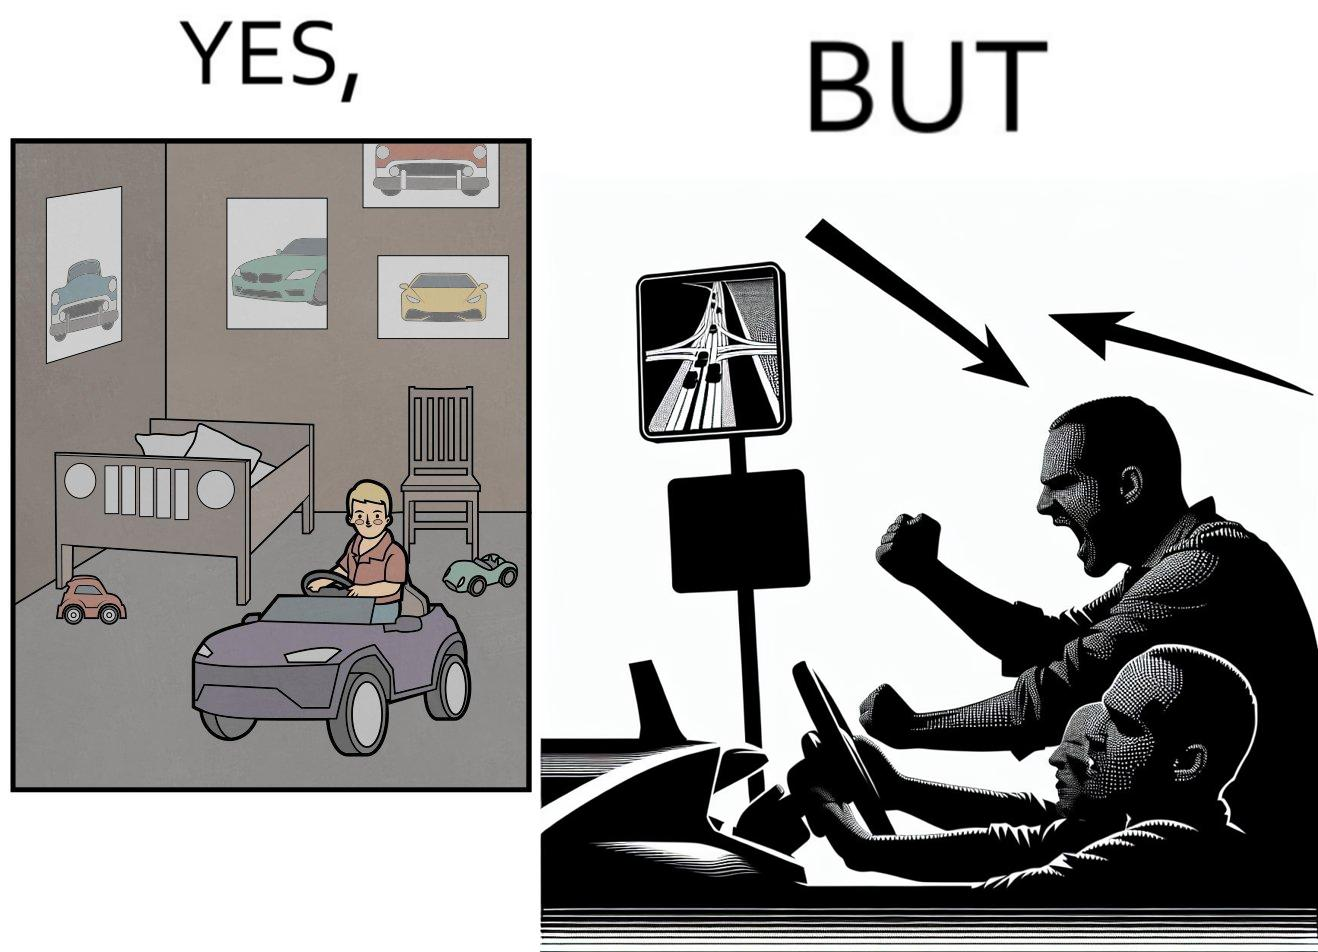Describe what you see in this image. The image is funny beaucse while the person as a child enjoyed being around cars, had various small toy cars and even rode a bigger toy car, as as grown up he does not enjoy being in a car during a traffic jam while he is driving . 